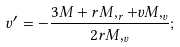<formula> <loc_0><loc_0><loc_500><loc_500>v ^ { \prime } = - \frac { 3 M + r M , _ { r } + v M , _ { v } } { 2 r M , _ { v } } ;</formula> 